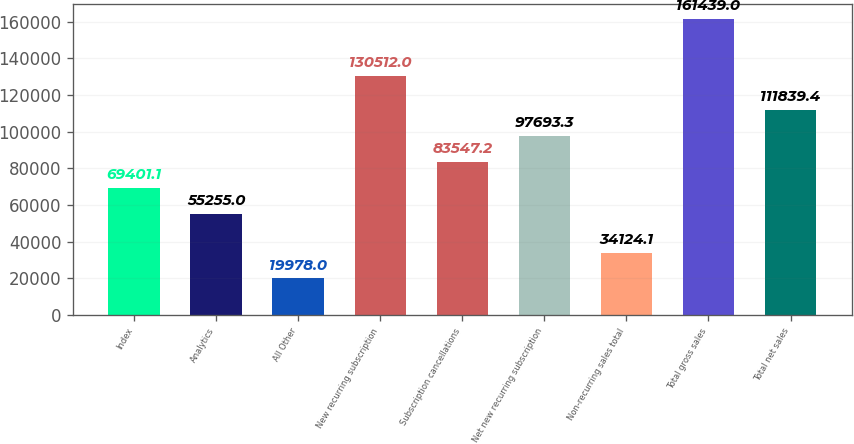Convert chart. <chart><loc_0><loc_0><loc_500><loc_500><bar_chart><fcel>Index<fcel>Analytics<fcel>All Other<fcel>New recurring subscription<fcel>Subscription cancellations<fcel>Net new recurring subscription<fcel>Non-recurring sales total<fcel>Total gross sales<fcel>Total net sales<nl><fcel>69401.1<fcel>55255<fcel>19978<fcel>130512<fcel>83547.2<fcel>97693.3<fcel>34124.1<fcel>161439<fcel>111839<nl></chart> 